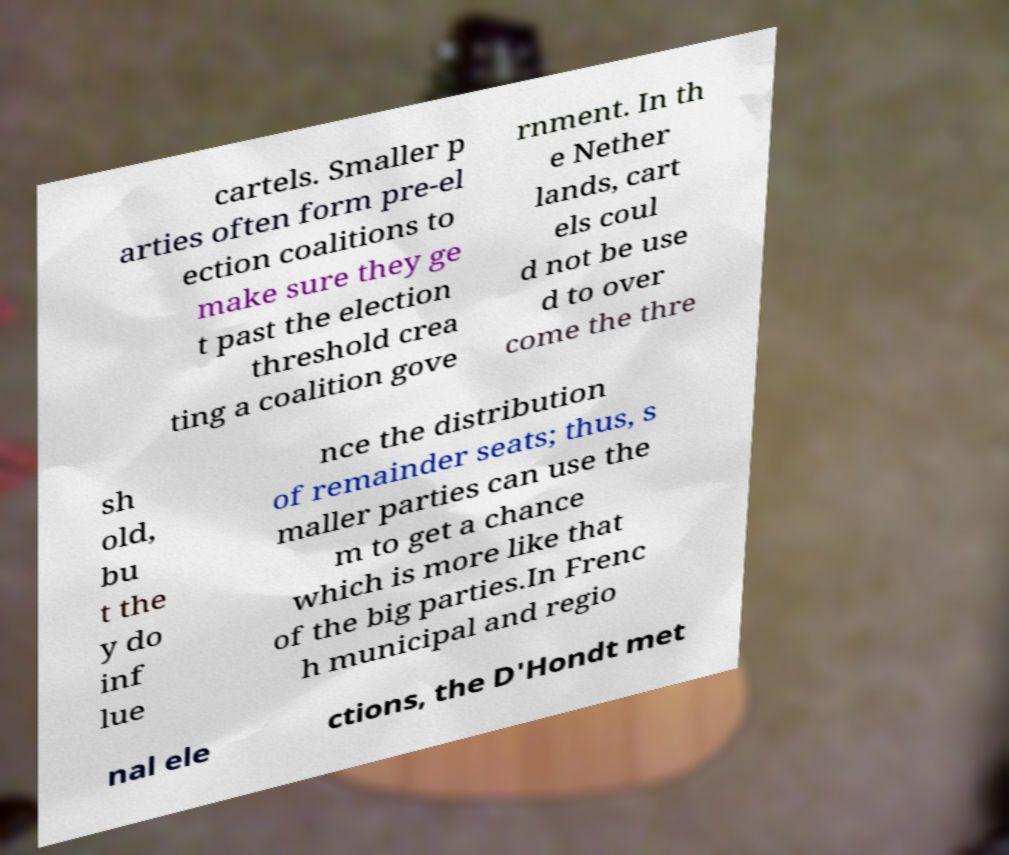Could you extract and type out the text from this image? cartels. Smaller p arties often form pre-el ection coalitions to make sure they ge t past the election threshold crea ting a coalition gove rnment. In th e Nether lands, cart els coul d not be use d to over come the thre sh old, bu t the y do inf lue nce the distribution of remainder seats; thus, s maller parties can use the m to get a chance which is more like that of the big parties.In Frenc h municipal and regio nal ele ctions, the D'Hondt met 